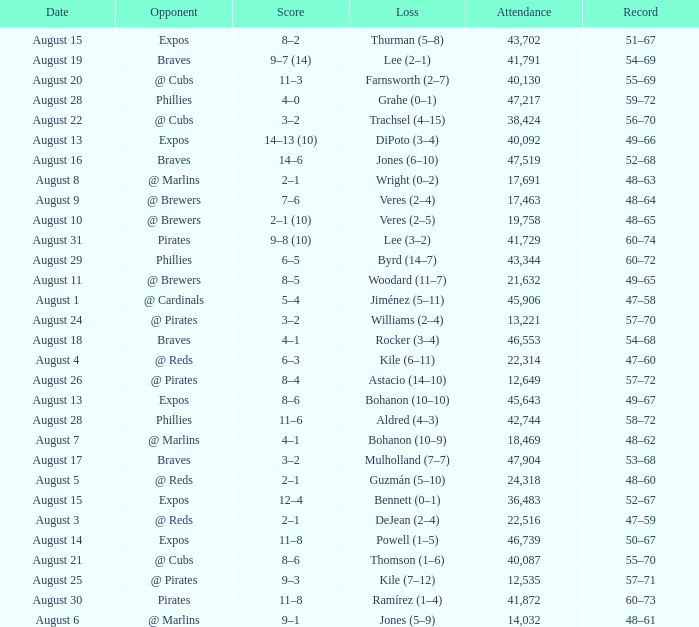What is the lowest attendance total on August 26? 12649.0. 